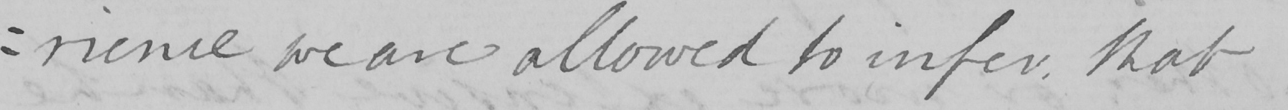What does this handwritten line say? : rience we are allowed to infer , that 